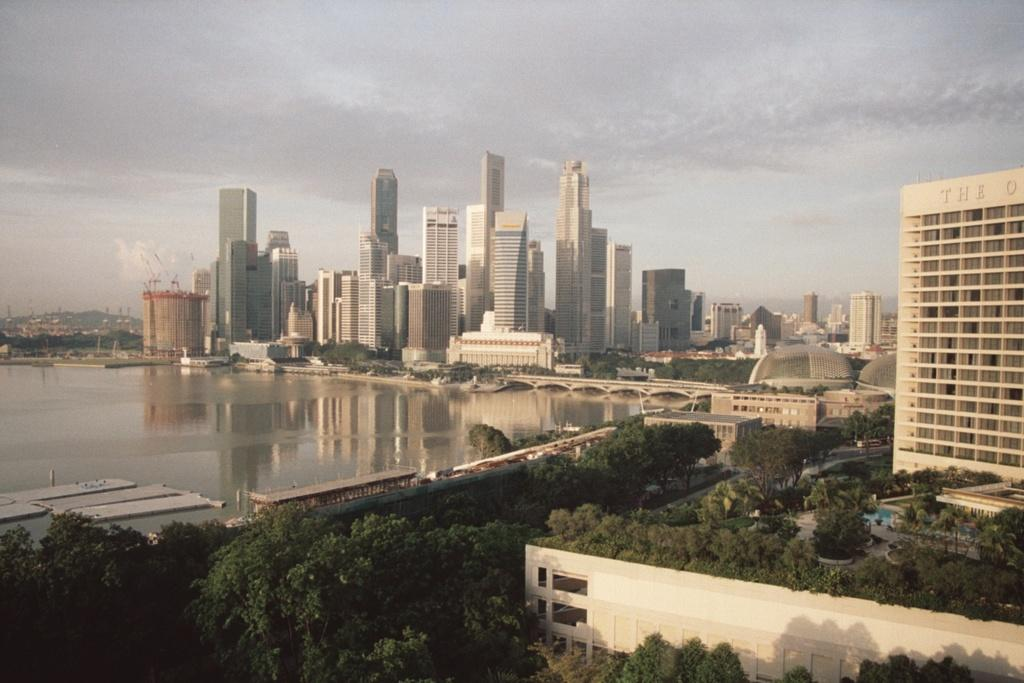What type of vegetation can be seen in the image? There are trees in the image. What is the color of the trees? The trees are green in color. What can be seen in the background of the image? There is water visible in the background of the image. What type of structures are present in the image? There are buildings in the image. What is the color of the buildings? The buildings are white and cream in color. What is the color of the sky in the image? The sky is white in color. How many jellyfish can be seen swimming in the water in the image? There are no jellyfish present in the image; it only features trees, water, buildings, and a white sky. What shape is the circle in the image? There is no circle present in the image. 